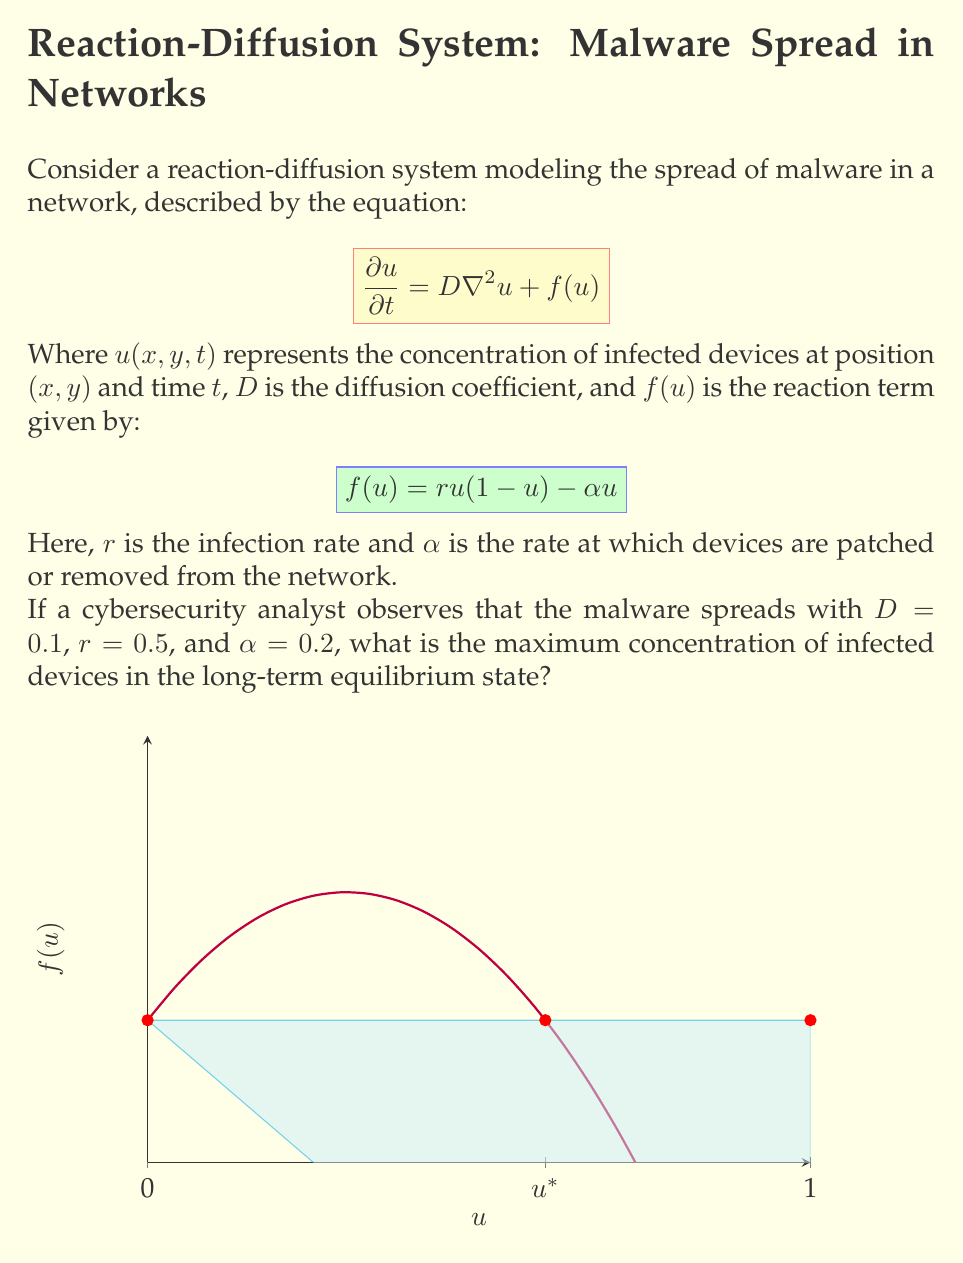Provide a solution to this math problem. To find the long-term equilibrium state, we need to solve for the steady-state solution where $\frac{\partial u}{\partial t} = 0$. This means:

1) Set $\frac{\partial u}{\partial t} = 0$ in the original equation:
   $$0 = D\nabla^2u + f(u)$$

2) In a homogeneous equilibrium, $\nabla^2u = 0$, so we only need to solve:
   $$0 = f(u) = ru(1-u) - \alpha u$$

3) Expand the equation:
   $$0 = 0.5u(1-u) - 0.2u = 0.5u - 0.5u^2 - 0.2u$$

4) Rearrange:
   $$0.5u^2 - 0.3u = 0$$

5) Factor out $u$:
   $$u(0.5u - 0.3) = 0$$

6) Solve for $u$:
   $u = 0$ or $0.5u - 0.3 = 0$
   $u = 0$ or $u = 0.6$

7) The non-zero solution $u = 0.6$ represents the stable equilibrium, as it's the point where $f(u)$ crosses the $u$-axis from positive to negative (see graph in the question).

Therefore, the maximum concentration of infected devices in the long-term equilibrium state is 0.6 or 60%.
Answer: 0.6 